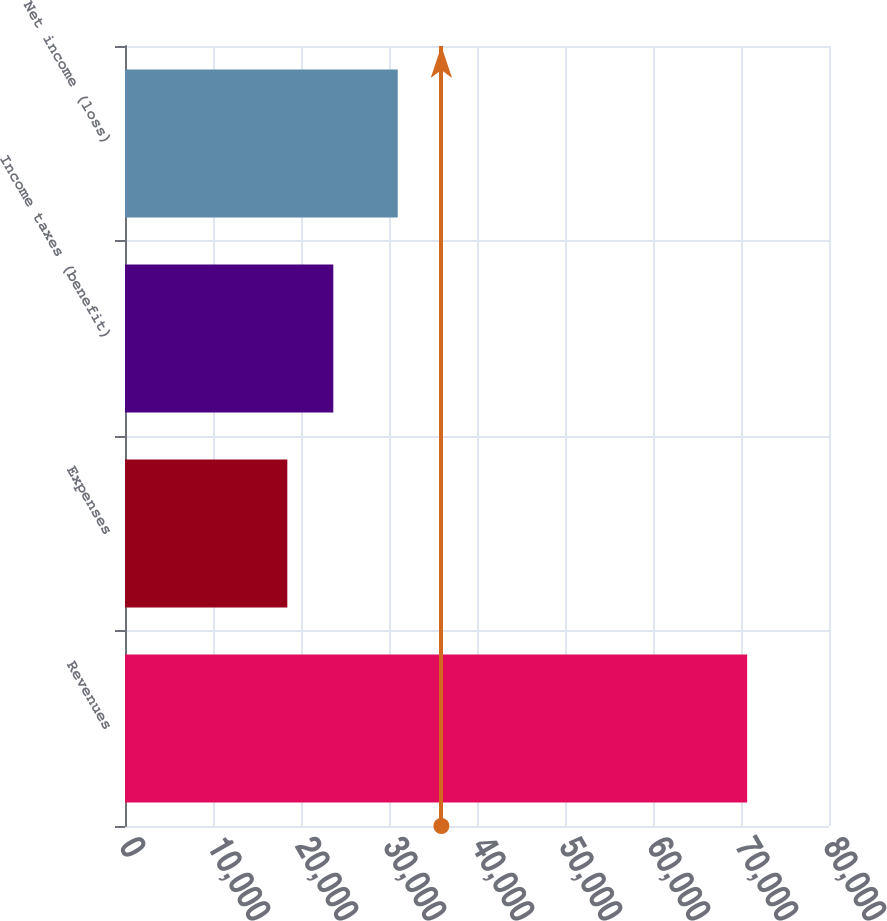<chart> <loc_0><loc_0><loc_500><loc_500><bar_chart><fcel>Revenues<fcel>Expenses<fcel>Income taxes (benefit)<fcel>Net income (loss)<nl><fcel>70698<fcel>18445<fcel>23670.3<fcel>30991<nl></chart> 